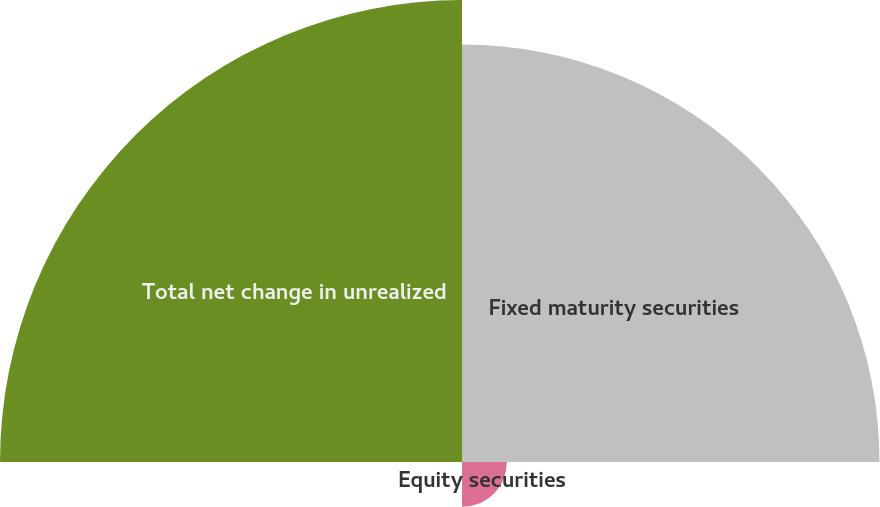<chart> <loc_0><loc_0><loc_500><loc_500><pie_chart><fcel>Fixed maturity securities<fcel>Equity securities<fcel>Other<fcel>Total net change in unrealized<nl><fcel>45.15%<fcel>4.85%<fcel>0.04%<fcel>49.96%<nl></chart> 